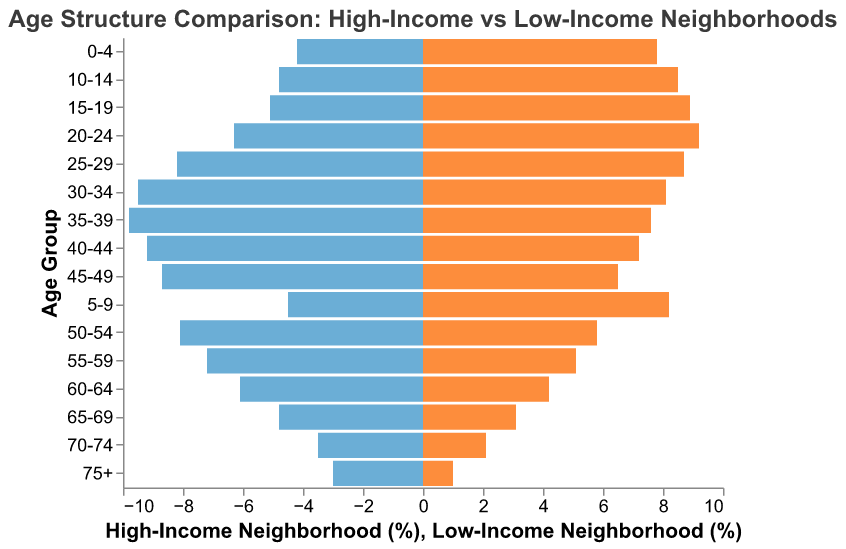What is the title of the figure? The title is located at the top of the figure. It reads "Age Structure Comparison: High-Income vs Low-Income Neighborhoods."
Answer: Age Structure Comparison: High-Income vs Low-Income Neighborhoods What are the age groups with the highest percentages in high-income and low-income neighborhoods? For high-income neighborhoods, the highest percentage falls in the 35-39 age group (9.8%). For low-income neighborhoods, it is the 20-24 age group with the highest percentage (9.2%).
Answer: 35-39 and 20-24 How do the percentages of the 0-4 age group compare between high-income and low-income neighborhoods? The high-income neighborhood has 4.2% of its population in the 0-4 age group, while the low-income neighborhood has 7.8%. Thus, the low-income neighborhood has a higher percentage by 3.6%.
Answer: Low-income has 3.6% more Which age group shows the smallest difference in percentage between high-income and low-income neighborhoods? The age group 25-29 shows the smallest difference in percentage: 8.2% for high-income and 8.7% for low-income, resulting in a difference of just 0.5%.
Answer: 25-29 with 0.5% What is the approximate percentage of people aged 75+ in both neighborhoods? For high-income neighborhoods, the percentage is 3.0%, and for low-income neighborhoods, it is 1.0%.
Answer: 3.0% and 1.0% In which age group does high-income neighborhood's percentage start to exceed the low-income neighborhood's percentage? From the age group 25-29, the percentage in high-income neighborhoods (8.2%) exceeds that of low-income neighborhoods (8.7%). This trend continues onward for the older age groups.
Answer: 25-29 What can you infer about the population distribution of older adults (65+) between the two neighborhoods? High-income neighborhoods have a consistently higher percentage of older adults in age groups 65-69 (4.8% vs. 3.1%), 70-74 (3.5% vs. 2.1%), and 75+ (3.0% vs. 1.0%), indicating a larger older population compared to low-income neighborhoods.
Answer: High-income neighborhoods have a larger older population Calculate the total percentage of people under 20 in both neighborhoods. Summing up the percentages of the age groups 0-4, 5-9, 10-14, and 15-19: 
High-income: 4.2% + 4.5% + 4.8% + 5.1% = 18.6%
Low-income: 7.8% + 8.2% + 8.5% + 8.9% = 33.4%
So, total percentages under 20 are 18.6% for high-income and 33.4% for low-income.
Answer: 18.6% and 33.4% Describe the general trend you observe as the age increases from 0-4 to 75+. As age increases, in low-income neighborhoods, the percentage of the population decreases steadily. In high-income neighborhoods, the percentage first increases, peaks around the mid-age groups (30-44), and then starts to decline.
Answer: Decreasing in low-income, peaks and declines in high-income 